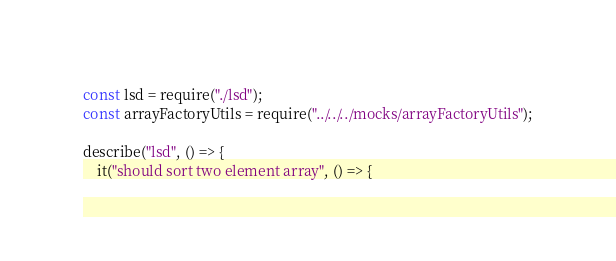<code> <loc_0><loc_0><loc_500><loc_500><_JavaScript_>const lsd = require("./lsd");
const arrayFactoryUtils = require("../../../mocks/arrayFactoryUtils");

describe("lsd", () => {
    it("should sort two element array", () => {</code> 